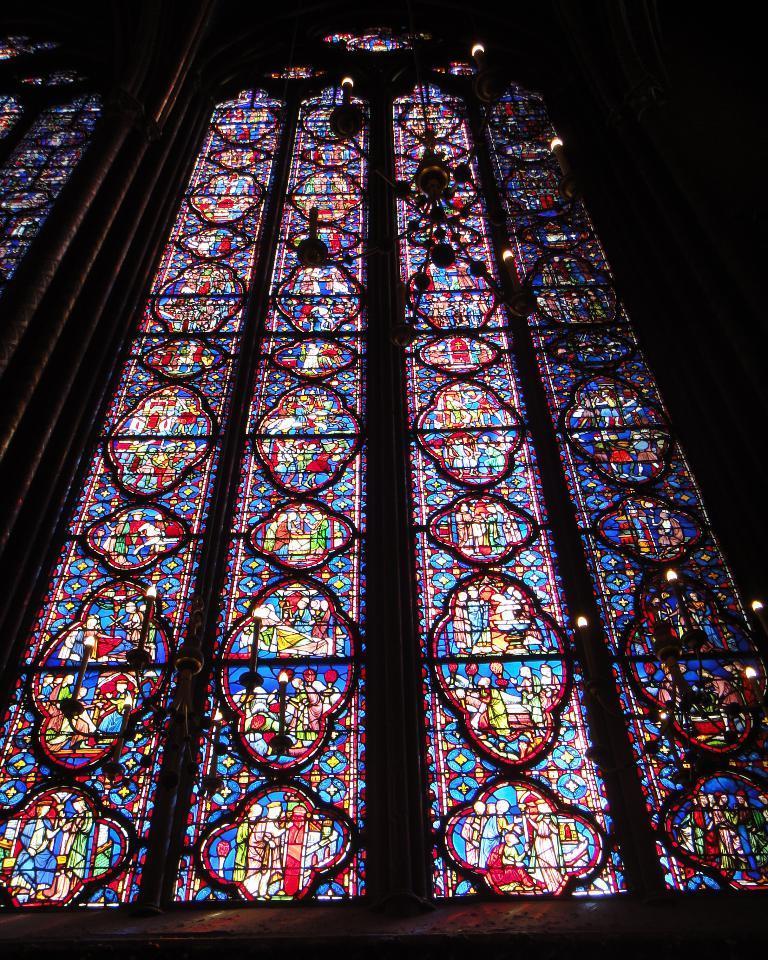Please provide a concise description of this image. In this image there is a wall having windows. The windows are painted with pictures. A chandelier is hanging from the roof. 